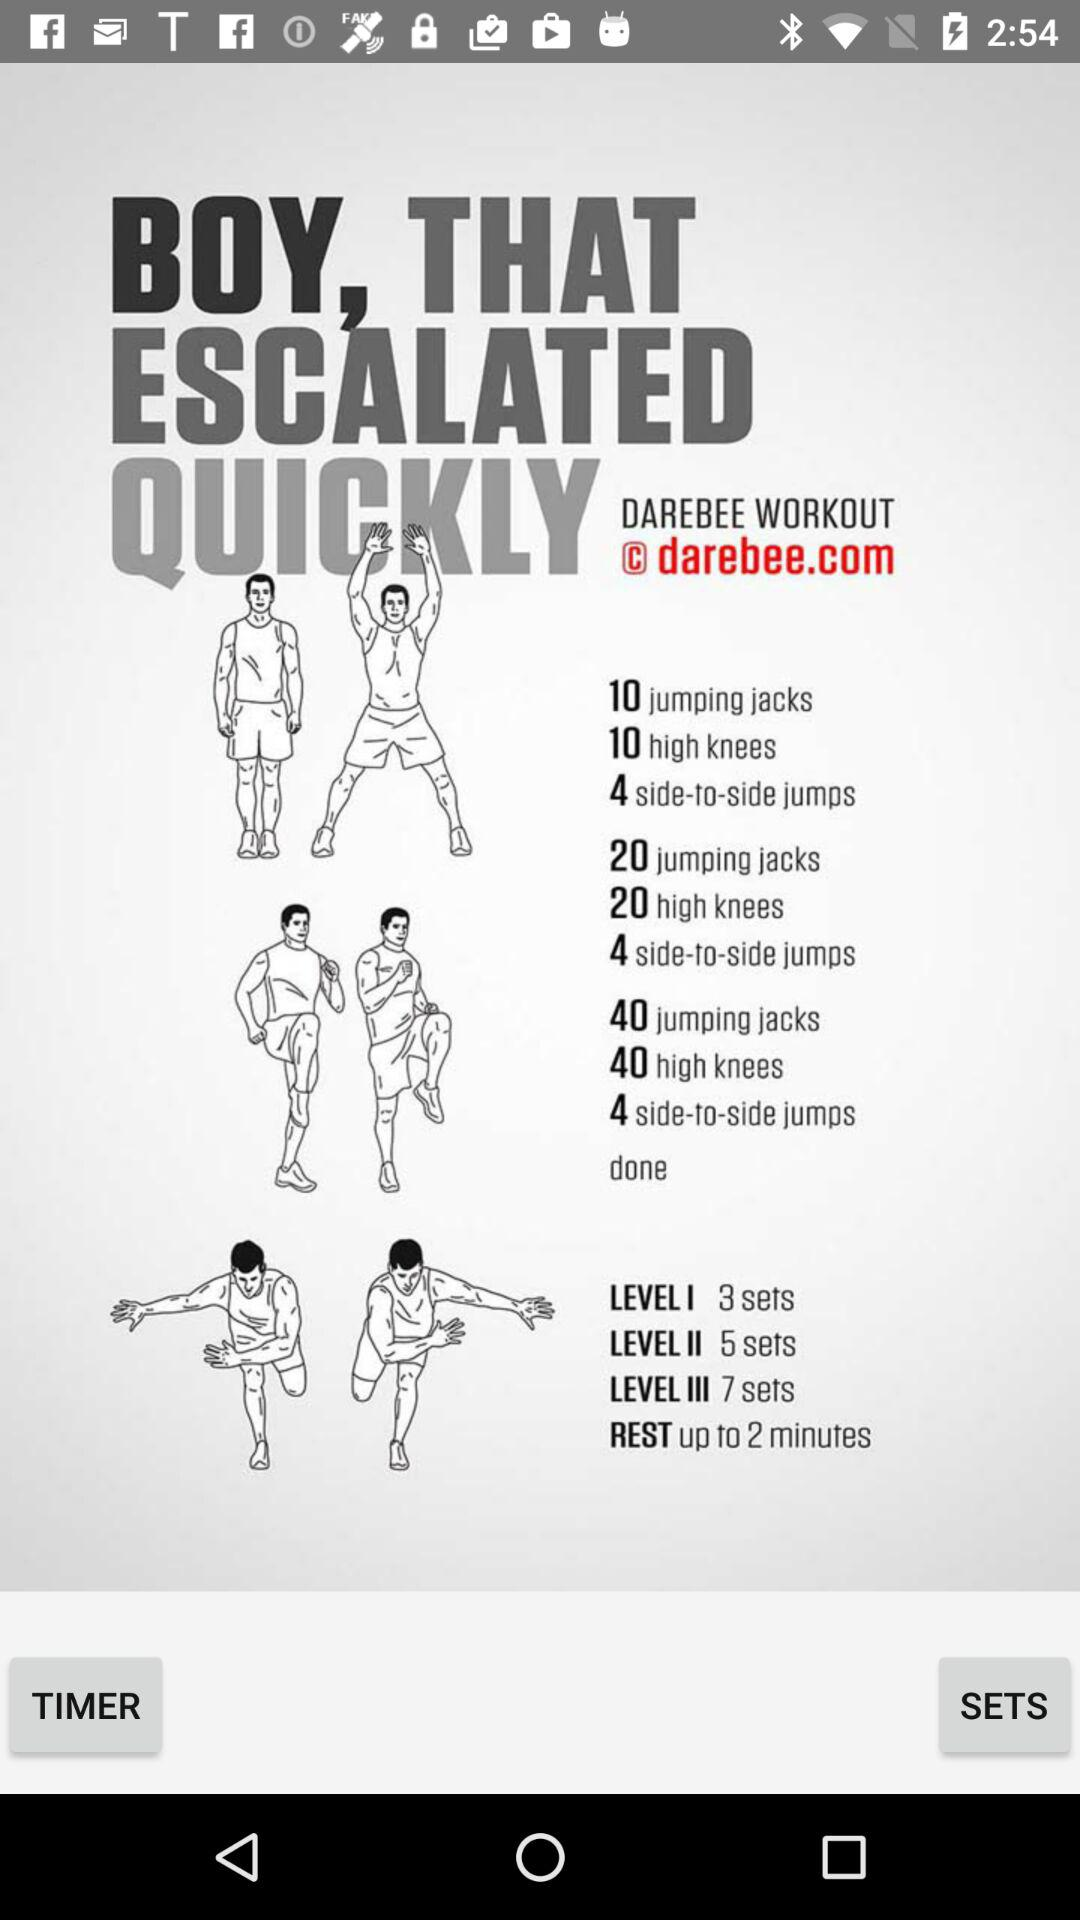How many sets are there in level 1? There are 3 sets in level 1. 